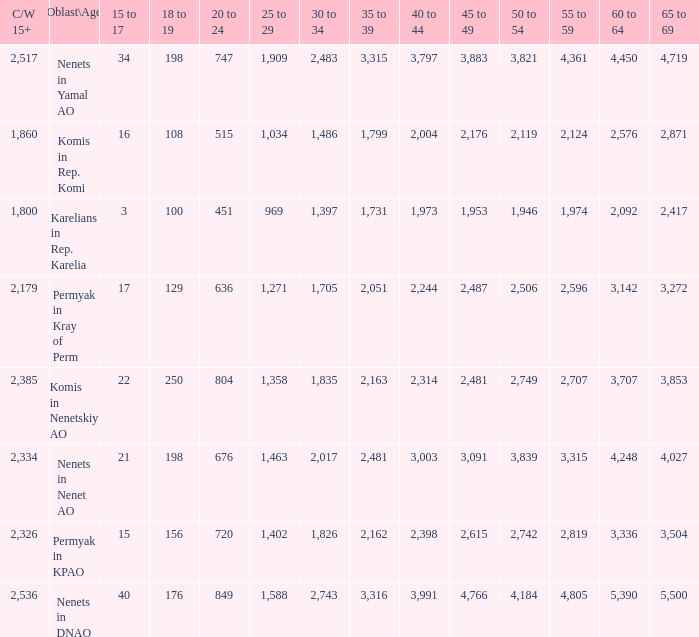What is the mean 55 to 59 when the C/W 15+ is greater than 2,385, and the 30 to 34 is 2,483, and the 35 to 39 is greater than 3,315? None. 